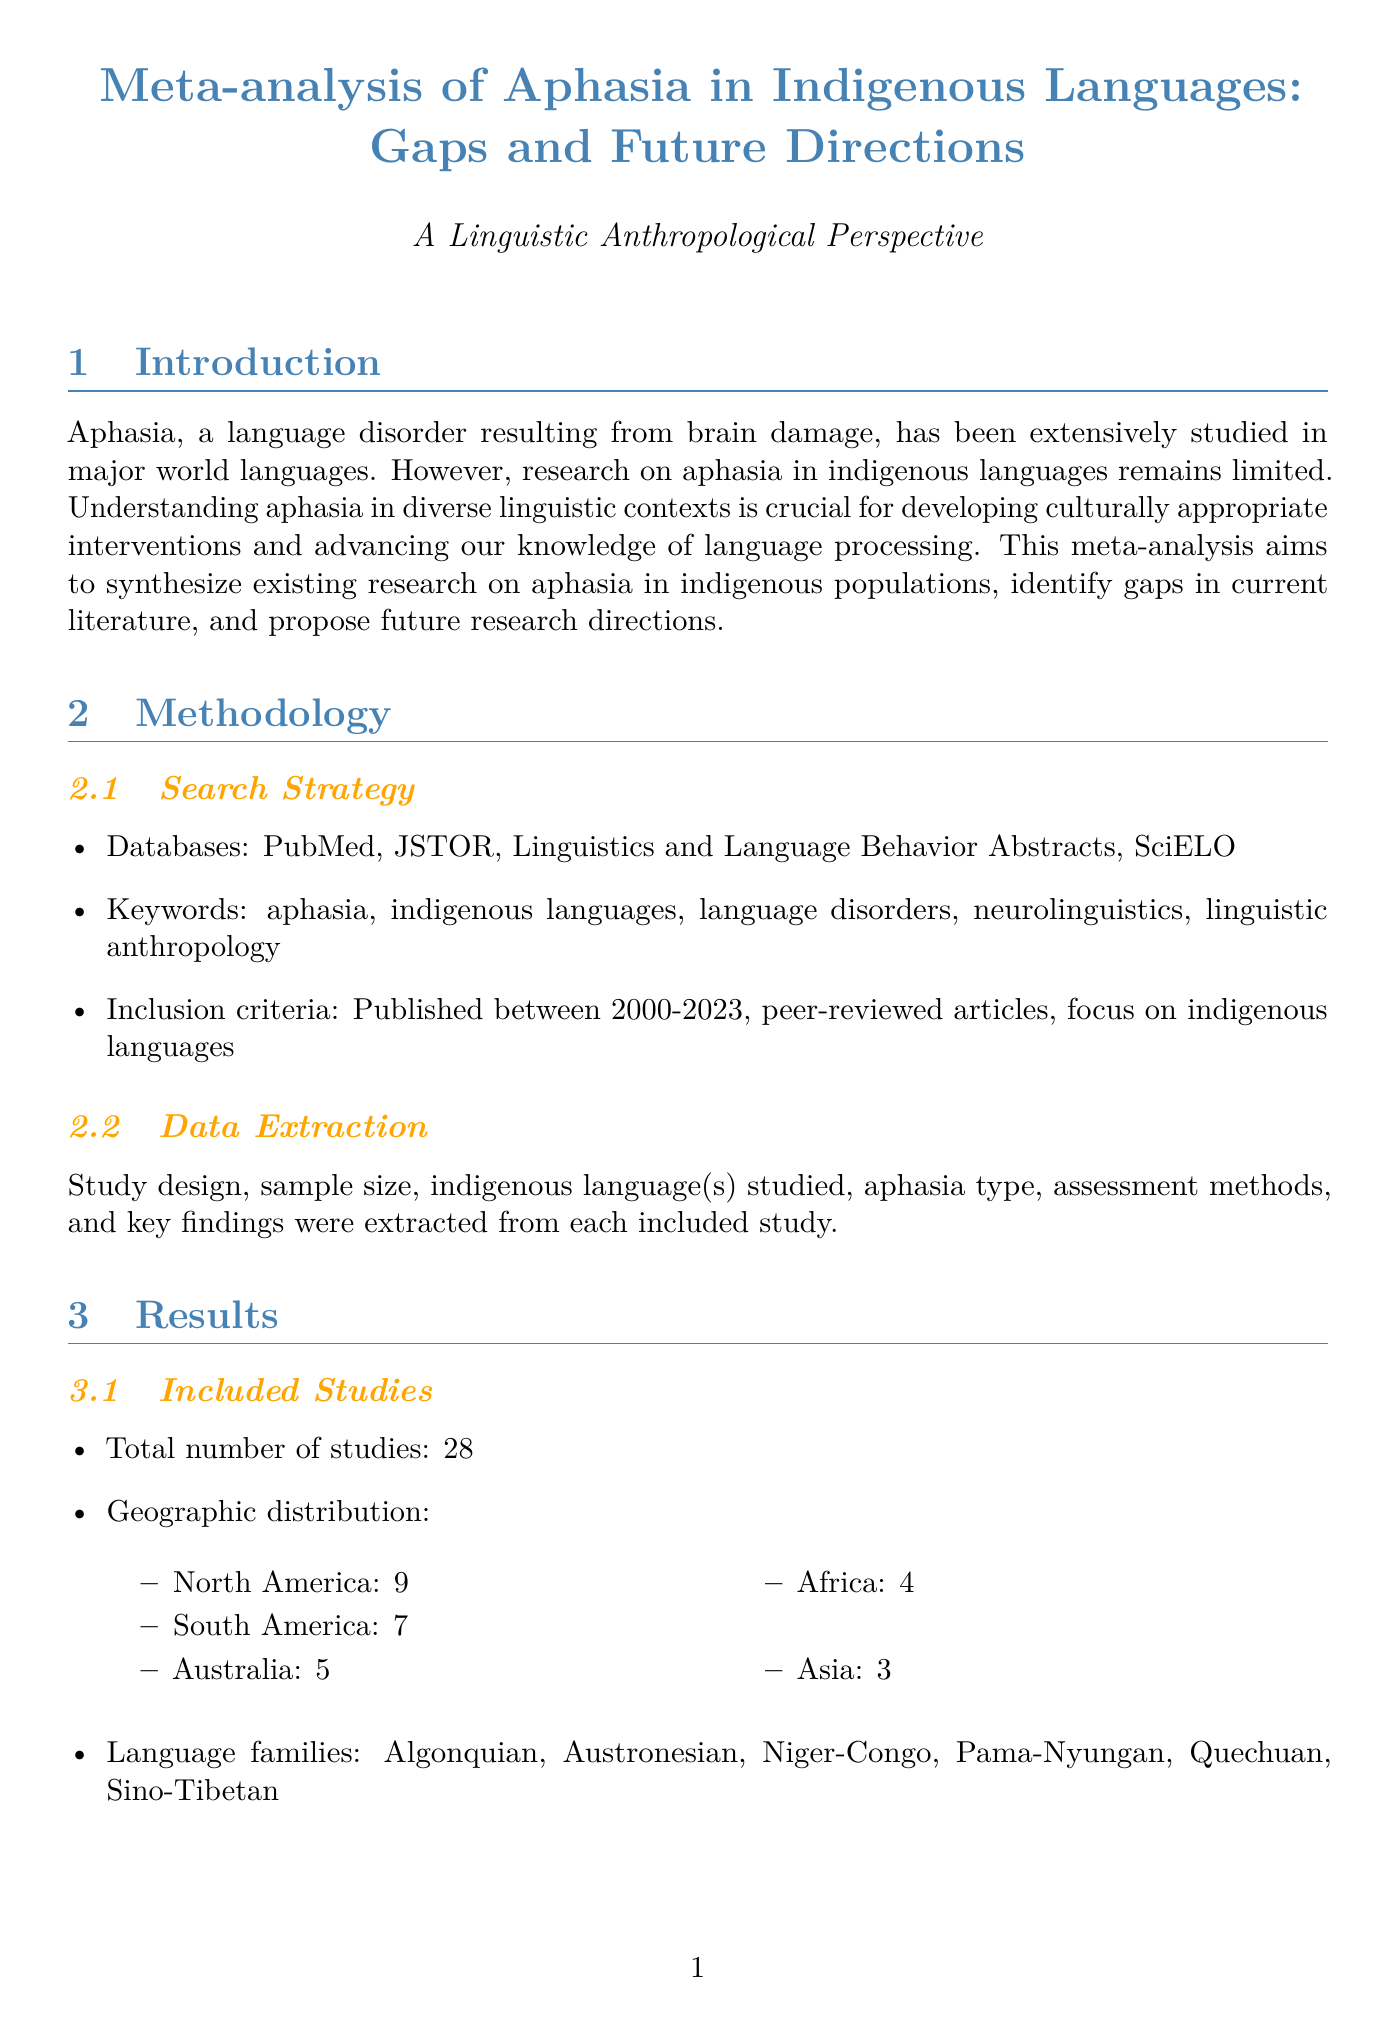what is the total number of studies included in the meta-analysis? The total number of studies is stated in the results section of the document as twenty-eight.
Answer: twenty-eight how many studies focus on indigenous populations in North America? The geographic distribution of included studies lists nine studies from North America.
Answer: nine what is one of the key findings related to assessment tools? The key findings mention that there are limited standardized assessment tools for indigenous languages.
Answer: limited standardized assessment tools what is a proposed research direction focusing on assessment tools? The proposed research directions suggest the development of culturally and linguistically appropriate assessment tools.
Answer: development of culturally and linguistically appropriate assessment tools which language family is noted in the research findings? The language families represented include Algonquian, which is one of the families listed.
Answer: Algonquian what year was the case study "Wernicke's Aphasia in a Quechua-Spanish Bilingual" published? The publication year is provided for the case study mentioned in the document, which is twenty twenty-one.
Answer: twenty twenty-one what type of studies are lacking according to the gaps in literature? The document states there is a lack of longitudinal studies on aphasia recovery in indigenous populations.
Answer: longitudinal studies how many studies were conducted in Australia? The results specify that five studies were conducted in Australia.
Answer: five what is one cultural aspect that affects aphasia mentioned in the findings? The findings indicate the influence of cultural factors on aphasia manifestation and recovery.
Answer: cultural factors 